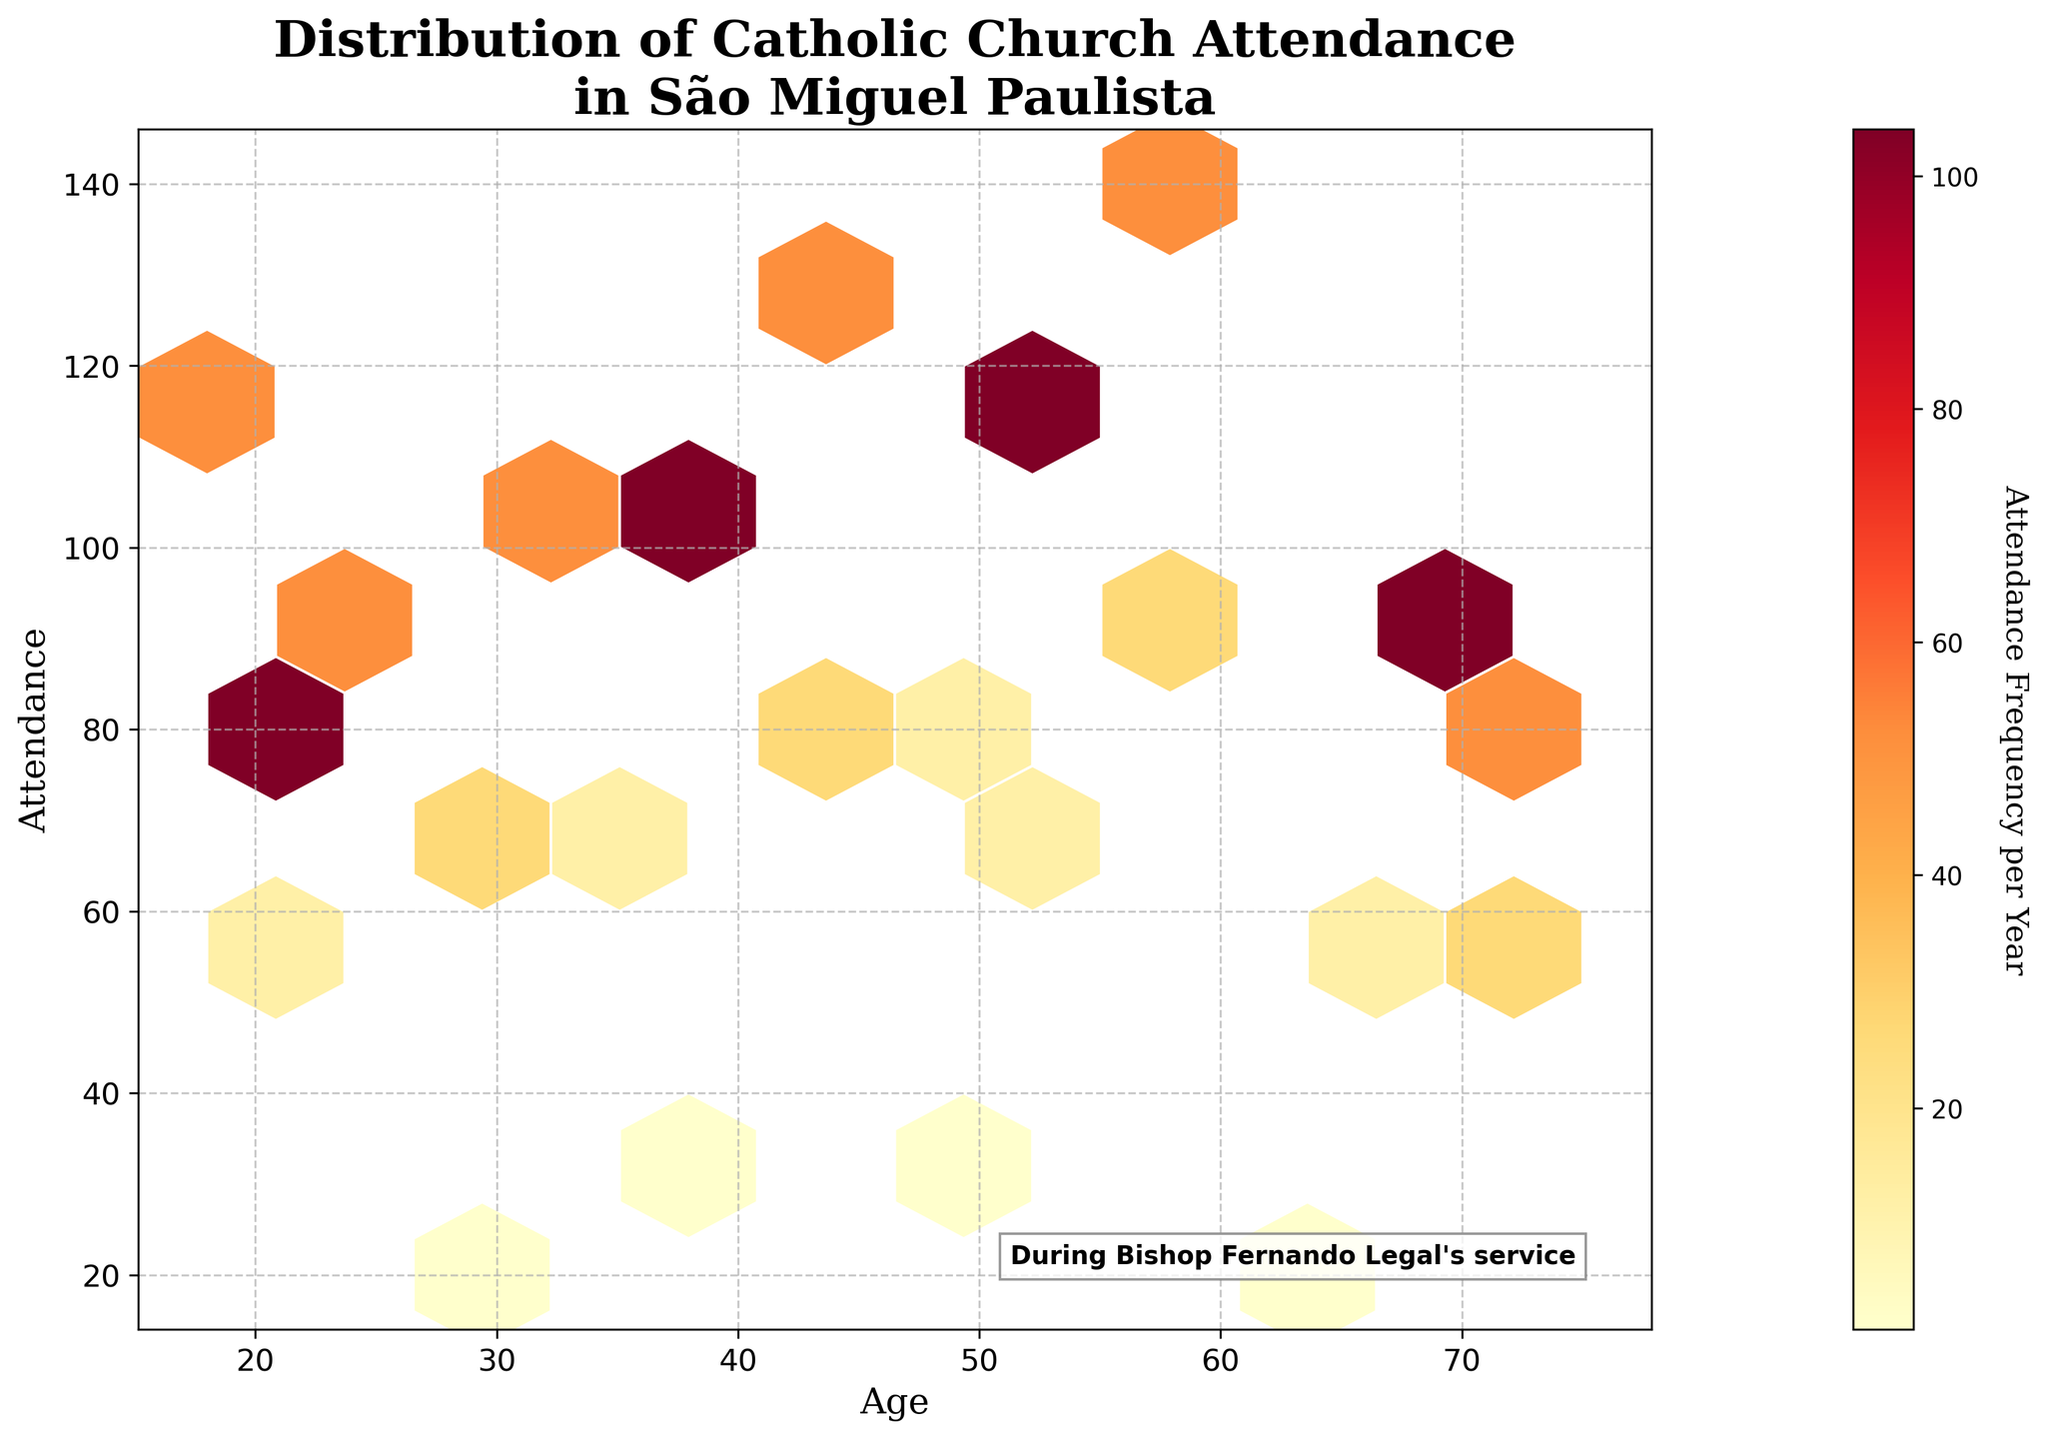How is the title of the plot worded? The title is displayed at the top of the plot and reads: "Distribution of Catholic Church Attendance in São Miguel Paulista"
Answer: Distribution of Catholic Church Attendance in São Miguel Paulista What does the color intensity represent? The color intensity on a hexbin plot typically represents the density of data points within each hexagonal bin. In this case, it shows the attendance frequency per year.
Answer: Attendance frequency What is the range of ages displayed in the plot? By looking at the x-axis, the ages range from the youngest at 18 to the oldest at 75.
Answer: 18 to 75 Which frequency has the highest attendance for the youngest age group? The youngest age group is 18 years, and by looking at the color-coded hexagons for this age, we can see that "Weekly" attendance frequency category shows the highest attendance.
Answer: Weekly How do attendance numbers change with increasing age for weekly attenders? For "Weekly" attenders, we see the attendance numbers generally increase with age, starting from 120 at age 18, peaking at 140 around age 60, and then decreasing to 80 at age 75.
Answer: Increases then decreases Among all age groups, which one shows the highest Catholic church attendance overall? By looking at the y-axis attendance values and corresponding hexbin colors, the age group 60 years shows the highest attendance value of 140 weekly.
Answer: 60 years What age group shows the lowest average attendance and which attendance frequency contributes to this? By observing the hexbin plot, age 65 shows the lowest average attendance with 20 attendances yearly for the "Yearly" frequency.
Answer: 65, Yearly For the "Twice Weekly" frequency, what is the trend of attendance as age increases from 20 to 70? The attendance for "Twice Weekly" increases first from age 20 (85) to age 52 (115) and then decreases towards age 70 (90).
Answer: Increases then decreases Which age group has the highest variation in attendance frequencies shown in different colors? The age group of 52 years shows different colored hexagons indicating various frequency levels, including significant "Weekly" and "Twice Weekly" attendances.
Answer: 52 years Is there a correlation between the church attendance frequency and age? There seems to be a positive correlation where higher attendance frequencies (like "Twice Weekly") are seen in middle-aged adults (up to age 52), while lower frequencies (like "Yearly") are more frequent in older and younger age groups.
Answer: Yes, positive correlation 